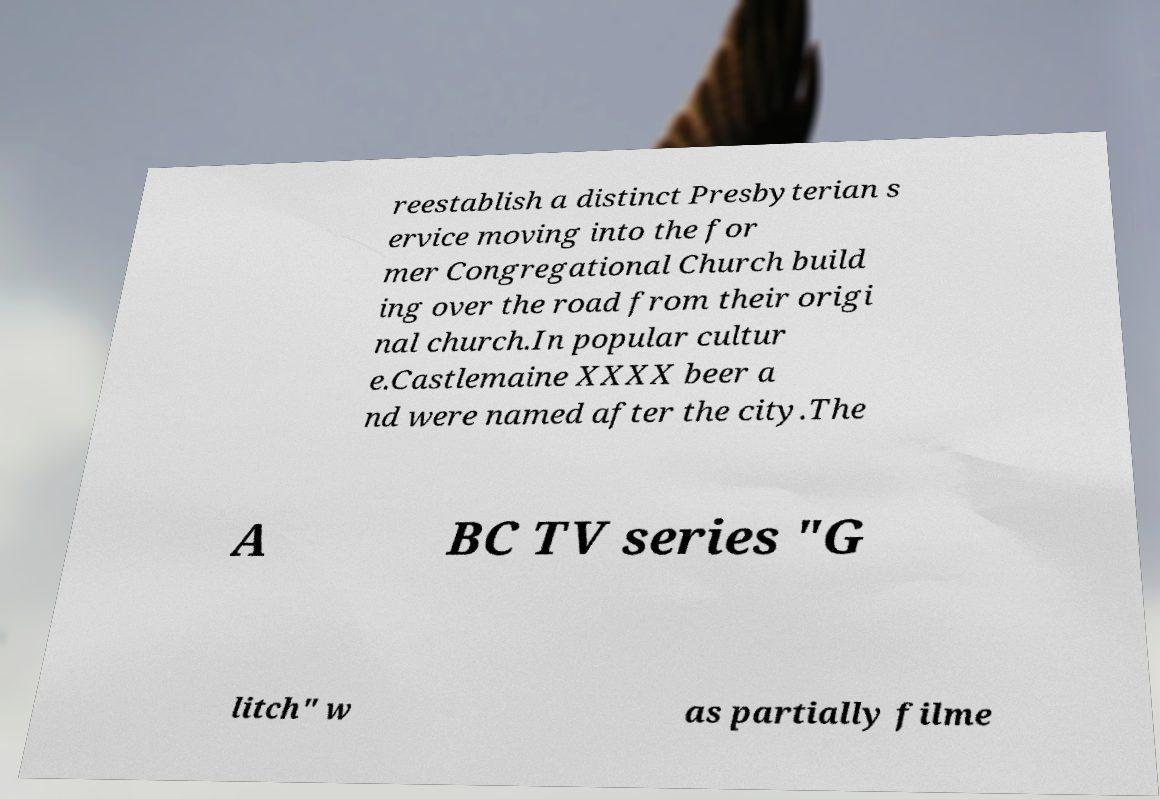There's text embedded in this image that I need extracted. Can you transcribe it verbatim? reestablish a distinct Presbyterian s ervice moving into the for mer Congregational Church build ing over the road from their origi nal church.In popular cultur e.Castlemaine XXXX beer a nd were named after the city.The A BC TV series "G litch" w as partially filme 